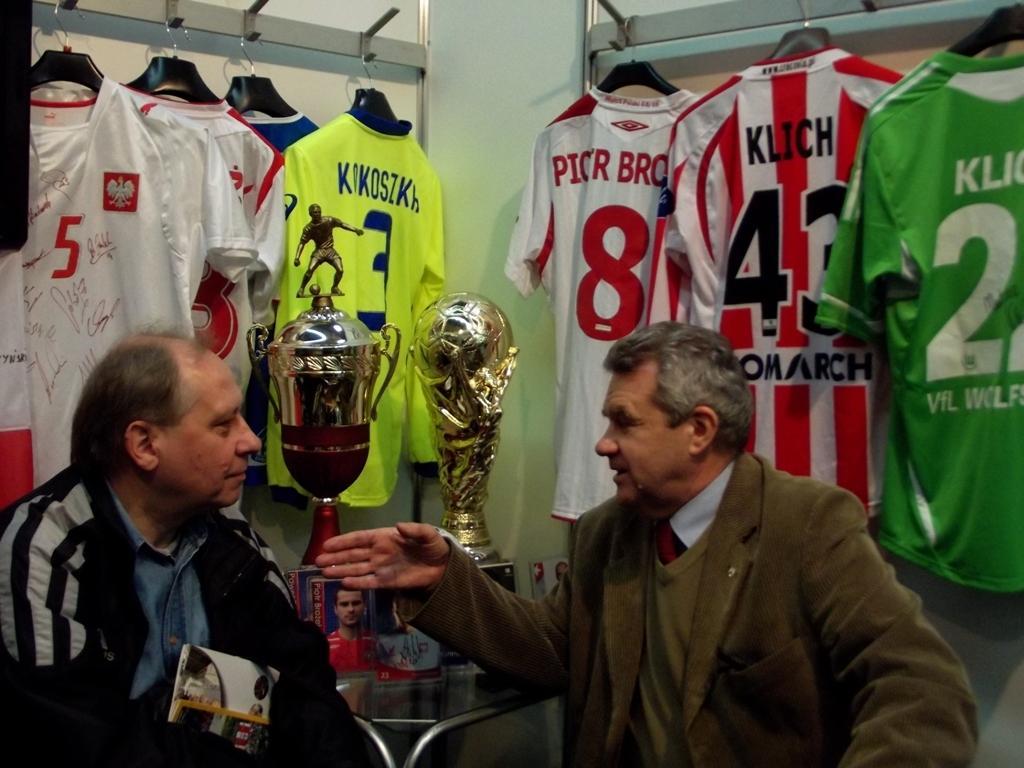<image>
Describe the image concisely. the number 8 jersey is behind the man 